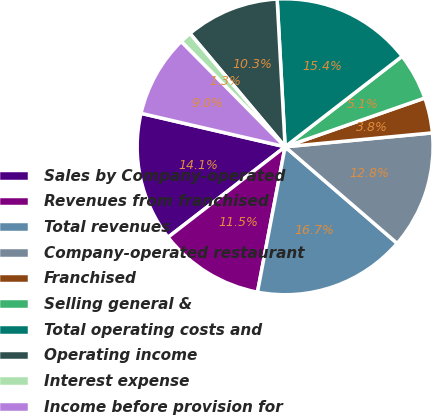Convert chart to OTSL. <chart><loc_0><loc_0><loc_500><loc_500><pie_chart><fcel>Sales by Company-operated<fcel>Revenues from franchised<fcel>Total revenues<fcel>Company-operated restaurant<fcel>Franchised<fcel>Selling general &<fcel>Total operating costs and<fcel>Operating income<fcel>Interest expense<fcel>Income before provision for<nl><fcel>14.1%<fcel>11.54%<fcel>16.67%<fcel>12.82%<fcel>3.85%<fcel>5.13%<fcel>15.38%<fcel>10.26%<fcel>1.28%<fcel>8.97%<nl></chart> 